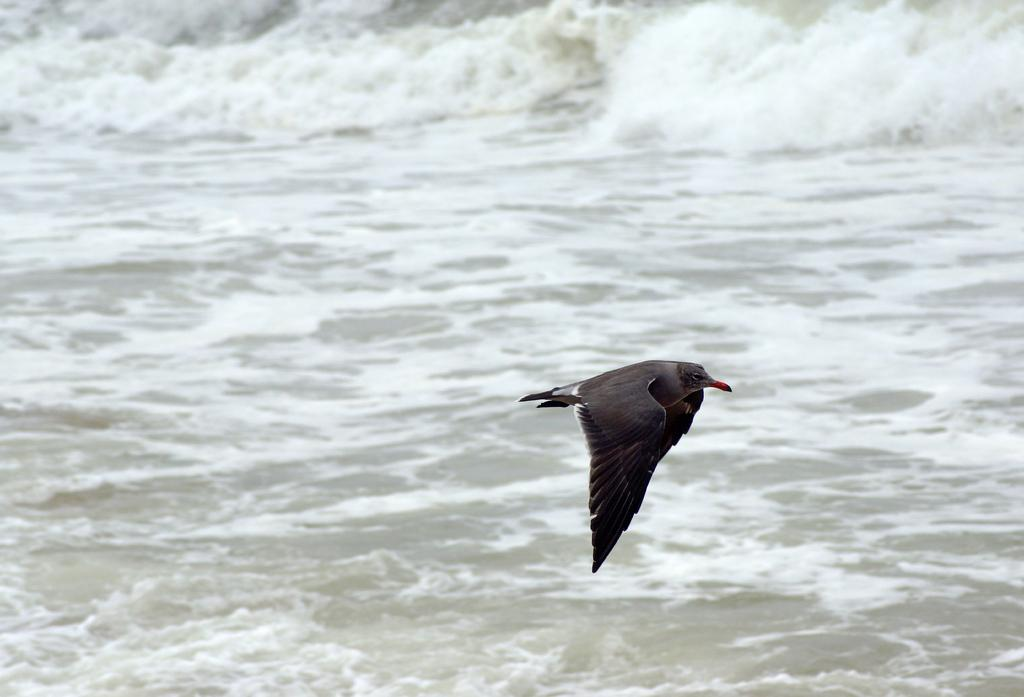What type of animal can be seen in the image? There is a bird in the image. What is the color of the bird? The bird is black in color. What is the bird doing in the image? The bird is flying in the air. What else can be seen in the image besides the bird? There is water visible in the image. How many beads are hanging from the bird's neck in the image? There are no beads present in the image; it features a black bird flying in the air. 